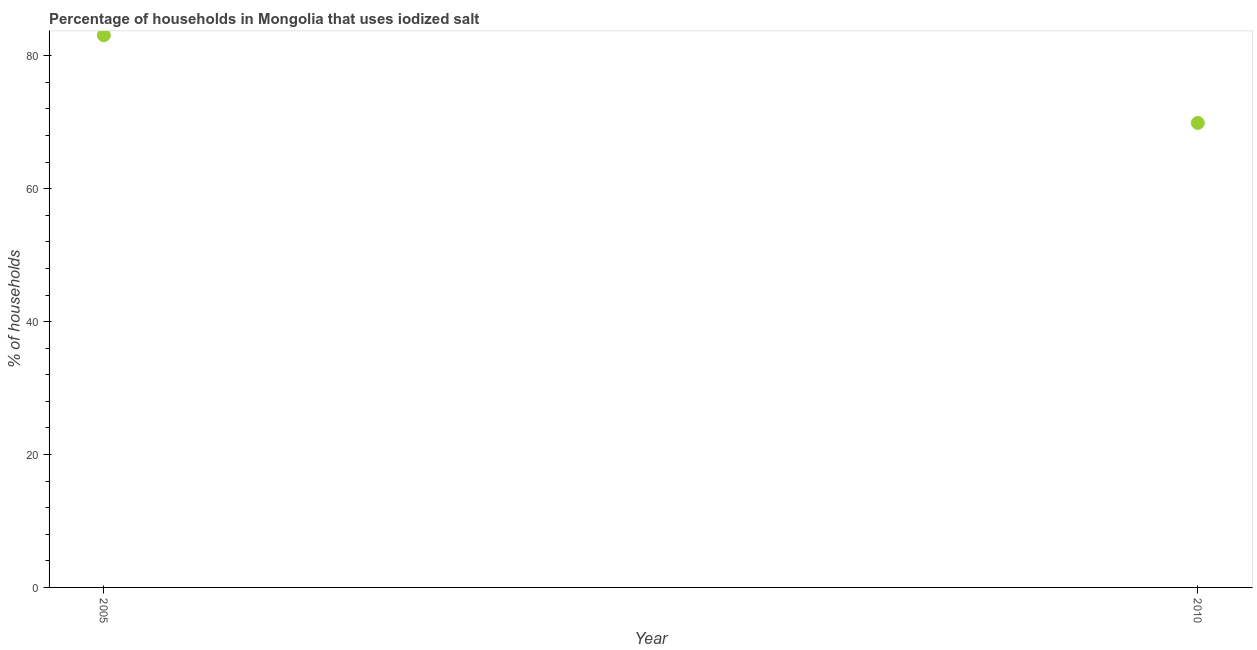What is the percentage of households where iodized salt is consumed in 2005?
Your answer should be compact. 83.1. Across all years, what is the maximum percentage of households where iodized salt is consumed?
Your response must be concise. 83.1. Across all years, what is the minimum percentage of households where iodized salt is consumed?
Your answer should be very brief. 69.9. In which year was the percentage of households where iodized salt is consumed maximum?
Your response must be concise. 2005. In which year was the percentage of households where iodized salt is consumed minimum?
Your response must be concise. 2010. What is the sum of the percentage of households where iodized salt is consumed?
Give a very brief answer. 153. What is the difference between the percentage of households where iodized salt is consumed in 2005 and 2010?
Provide a succinct answer. 13.2. What is the average percentage of households where iodized salt is consumed per year?
Offer a very short reply. 76.5. What is the median percentage of households where iodized salt is consumed?
Keep it short and to the point. 76.5. What is the ratio of the percentage of households where iodized salt is consumed in 2005 to that in 2010?
Offer a very short reply. 1.19. Is the percentage of households where iodized salt is consumed in 2005 less than that in 2010?
Provide a succinct answer. No. In how many years, is the percentage of households where iodized salt is consumed greater than the average percentage of households where iodized salt is consumed taken over all years?
Keep it short and to the point. 1. How many years are there in the graph?
Make the answer very short. 2. Are the values on the major ticks of Y-axis written in scientific E-notation?
Offer a very short reply. No. Does the graph contain any zero values?
Offer a very short reply. No. What is the title of the graph?
Your answer should be compact. Percentage of households in Mongolia that uses iodized salt. What is the label or title of the Y-axis?
Keep it short and to the point. % of households. What is the % of households in 2005?
Make the answer very short. 83.1. What is the % of households in 2010?
Provide a short and direct response. 69.9. What is the difference between the % of households in 2005 and 2010?
Your response must be concise. 13.2. What is the ratio of the % of households in 2005 to that in 2010?
Keep it short and to the point. 1.19. 